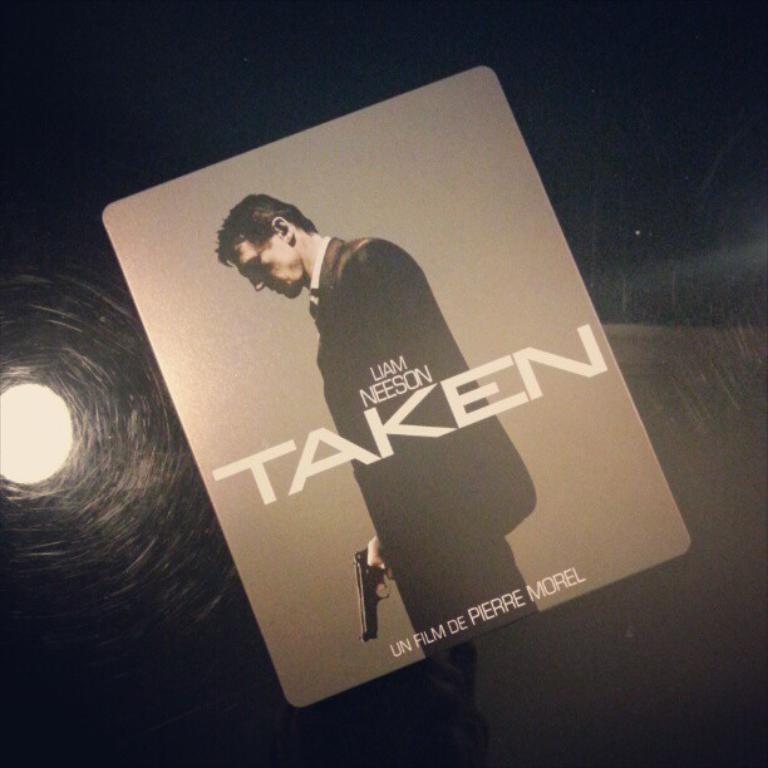Please provide a concise description of this image. In this image there is a poster with some text and image and behind the poster there is light. 